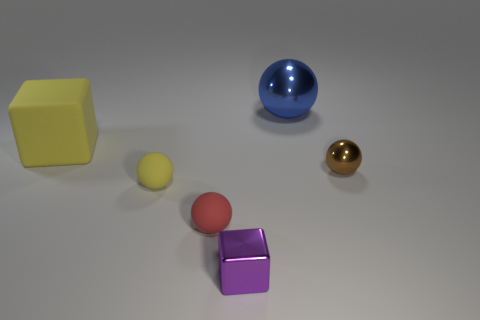Are there fewer tiny red matte balls that are left of the red matte sphere than red objects?
Make the answer very short. Yes. Is the size of the yellow sphere the same as the red object?
Make the answer very short. Yes. There is a cube that is made of the same material as the brown object; what is its size?
Give a very brief answer. Small. What number of other large things have the same color as the large metallic object?
Make the answer very short. 0. Is the number of tiny yellow rubber balls behind the blue object less than the number of balls on the left side of the red matte sphere?
Ensure brevity in your answer.  Yes. There is a small rubber object that is on the left side of the red sphere; is it the same shape as the large metallic object?
Offer a terse response. Yes. Are there any other things that are made of the same material as the yellow ball?
Offer a very short reply. Yes. Is the block in front of the small brown thing made of the same material as the big cube?
Ensure brevity in your answer.  No. What material is the tiny thing that is right of the metal sphere behind the tiny brown ball that is to the right of the red matte sphere made of?
Offer a very short reply. Metal. What number of other objects are there of the same shape as the red rubber object?
Provide a succinct answer. 3. 